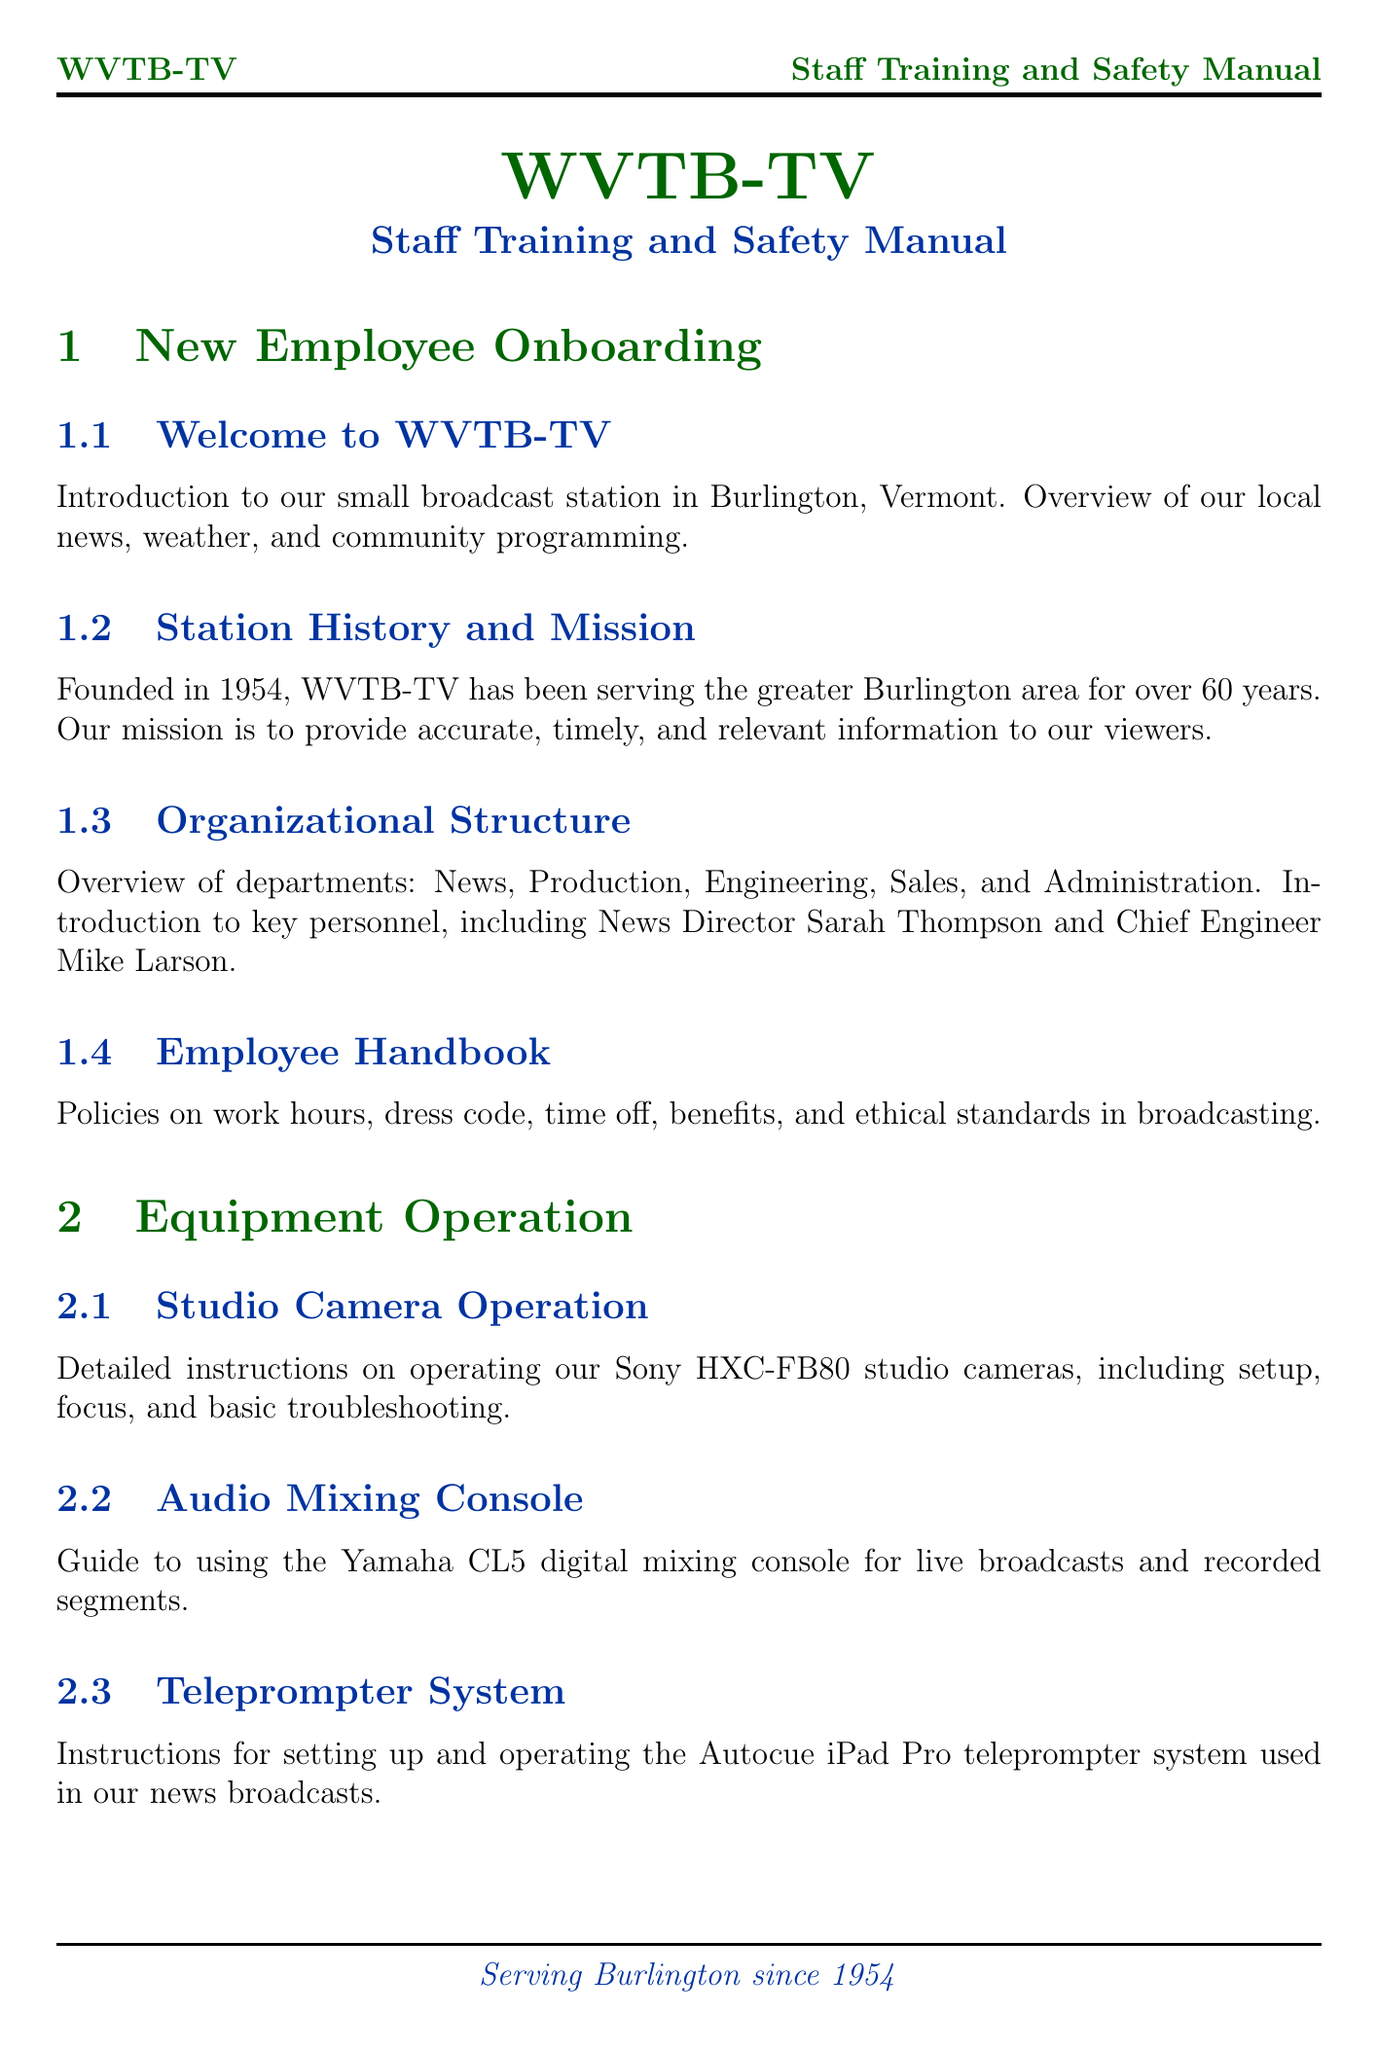What year was WVTB-TV founded? The document states that WVTB-TV was founded in 1954.
Answer: 1954 Who is the News Director at WVTB-TV? The document introduces Sarah Thompson as the News Director.
Answer: Sarah Thompson What type of mixing console is mentioned in the equipment operation section? The document specifies the Yamaha CL5 as the digital mixing console to be used.
Answer: Yamaha CL5 What is the focus of the Emergency Procedures section? This section includes protocols for severe weather, power outages, and medical emergencies, which are all emergency situations.
Answer: Emergency situations What should crews working on location adhere to according to the Field Safety guidelines? The guidelines emphasize weather precautions, equipment transport, and interaction with the public.
Answer: Weather precautions What does the Employee Handbook cover? It includes policies on work hours, dress code, time off, benefits, and ethical standards.
Answer: Work hours, dress code, time off, benefits, ethical standards What is the main mission of WVTB-TV? The document outlines the mission as providing accurate, timely, and relevant information to viewers.
Answer: Accurate, timely, relevant information How often should fire drills be conducted according to the Fire Safety section? The document includes an annual schedule for fire drills and participation requirements.
Answer: Annual What does the Privacy and Data Protection section address? It provides guidelines for handling sensitive information and protecting sources while complying with laws.
Answer: Sensitive information, sources, laws 